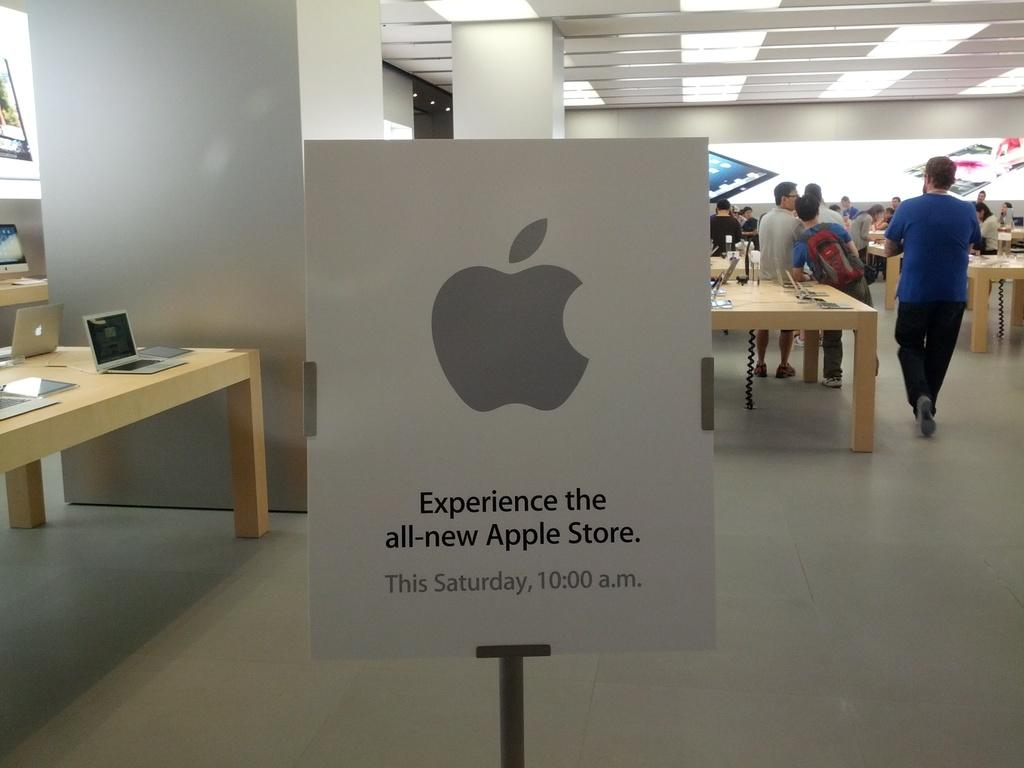What can be seen in the image involving people? There are people standing in the image. What objects are present in the image that might be used for work or leisure? There are tables and laptops on the tables visible in the image. What additional feature can be seen in the image? There is a board visible in the image. What type of goose is sitting on the board in the image? There is no goose present in the image; the board is visible but does not have any animals on it. What scientific discovery is being discussed at the tables in the image? The image does not provide any information about scientific discoveries or discussions taking place at the tables. 